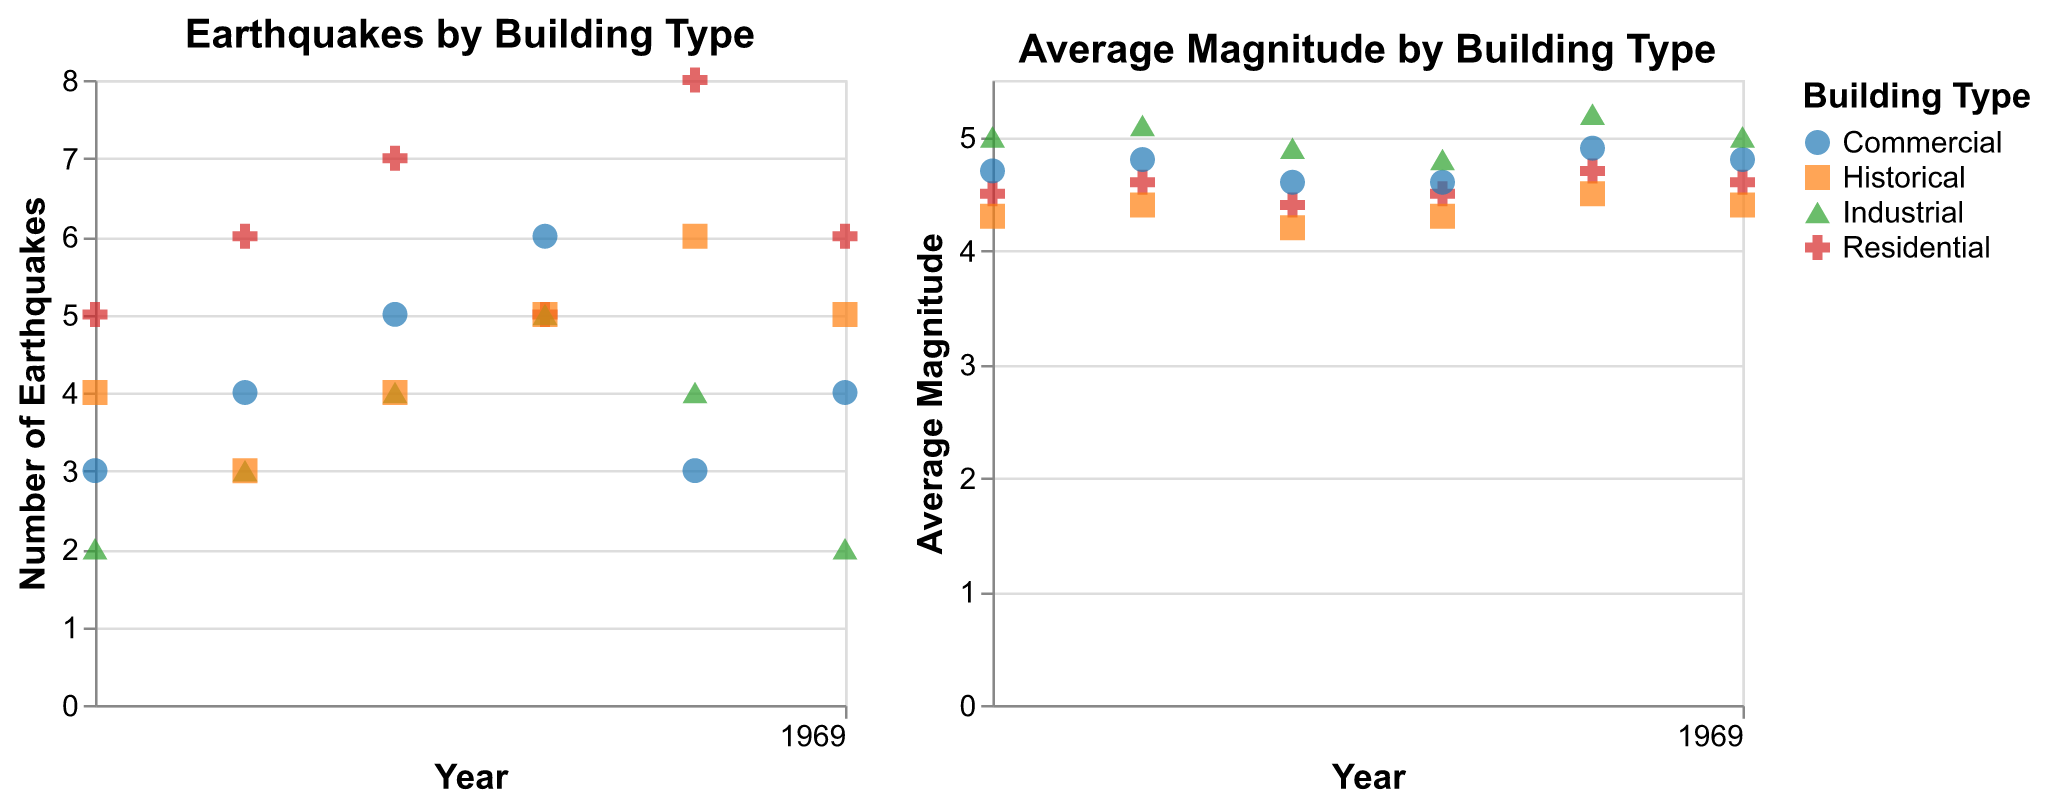What is the highest number of earthquakes recorded for residential buildings in a single year? To determine this, you need to check the scatter plot for "Number of Earthquakes" by "Year" for the residential buildings, and find the highest point. The highest number of earthquakes for residential buildings appears to be 8, in 2004.
Answer: 8 Which building type experienced the lowest average magnitude in 2002? Look for the points labeled 2002 on the "Average Magnitude by Building Type" plot and identify which building type has the lowest y-value. Historical buildings have the lowest average magnitude of 4.2 in 2002.
Answer: Historical How did the number of earthquakes for industrial buildings change from 2000 to 2005? Check the "Earthquakes by Building Type" subplot for the industrial points from 2000 to 2005. In 2000, the number of earthquakes was 2, then it increased to 4 in 2002 and 5 in 2003, before falling back to 2 by 2005. So the number initially increased and then returned to the same starting point.
Answer: It fluctuated and returned to the initial value What's the total number of earthquakes recorded for commercial buildings across all years? Find all the points representing commercial buildings in the "Number of Earthquakes" scatter plot and sum their y-values. The totals are 3 + 4 + 5 + 6 + 3 + 4, which equates to 25.
Answer: 25 Which year had the highest average magnitude for industrial buildings and what was it? On the "Average Magnitude by Building Type" plot, look for the industrial data points and identify the highest y-value along with its corresponding year. The highest average magnitude for industrial buildings is 5.2, in 2004.
Answer: 2004, 5.2 Compare the total number of earthquakes in residential buildings for the years 2003 and 2005. Which year had more and by how much? Check the "Earthquakes by Building Type" plot for the residential points in 2003 and 2005. In 2003, there were 5 earthquakes, and in 2005, there were 6. Thus, 2005 had one more earthquake compared to 2003.
Answer: 2005 by 1 What building type had the most consistent (least variable) number of earthquakes over the years? Evaluate the "Earthquakes by Building Type" scatter plot and observe the spread of data points over the years. Residential buildings have data points varying between 5 to 8 earthquakes, while other types like commercial and industrial fluctuate more.
Answer: Residential In which year did the historical buildings experience the highest number of earthquakes and what was the count? Look at the "Earthquakes by Building Type" plot for data points related to historical buildings and find the highest point. The highest number of earthquakes for historical buildings occurred in 2004 with a count of 6.
Answer: 2004, 6 What is the difference in the number of earthquakes for residential buildings between the years 2001 and 2004? Identify the number of earthquakes for residential buildings in the years 2001 and 2004 from the scatter plot. In 2001, the number was 6, and in 2004, it was 8. The difference is 8 - 6 = 2.
Answer: 2 Which building type has the highest average magnitude consistently over the years? Compare the "Average Magnitude by Building Type" subplot and observe the trend lines for various building types. Industrial buildings generally have higher average magnitudes compared to other building types.
Answer: Industrial 